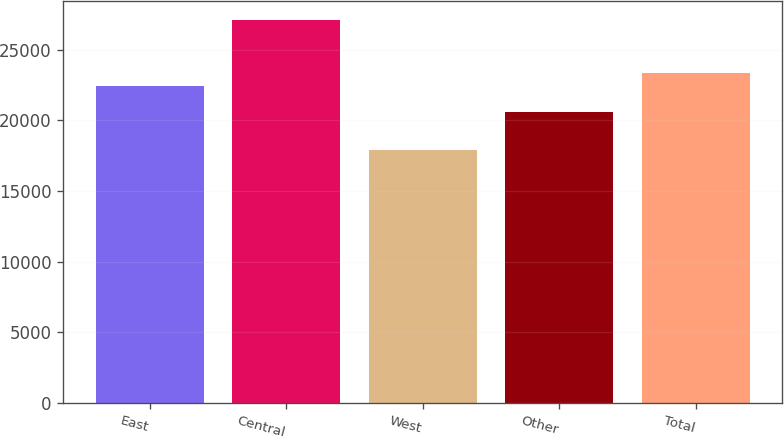Convert chart. <chart><loc_0><loc_0><loc_500><loc_500><bar_chart><fcel>East<fcel>Central<fcel>West<fcel>Other<fcel>Total<nl><fcel>22400<fcel>27100<fcel>17900<fcel>20600<fcel>23320<nl></chart> 